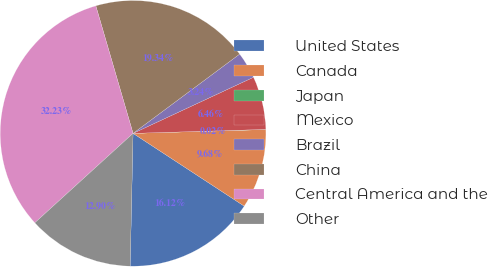Convert chart. <chart><loc_0><loc_0><loc_500><loc_500><pie_chart><fcel>United States<fcel>Canada<fcel>Japan<fcel>Mexico<fcel>Brazil<fcel>China<fcel>Central America and the<fcel>Other<nl><fcel>16.12%<fcel>9.68%<fcel>0.02%<fcel>6.46%<fcel>3.24%<fcel>19.34%<fcel>32.23%<fcel>12.9%<nl></chart> 